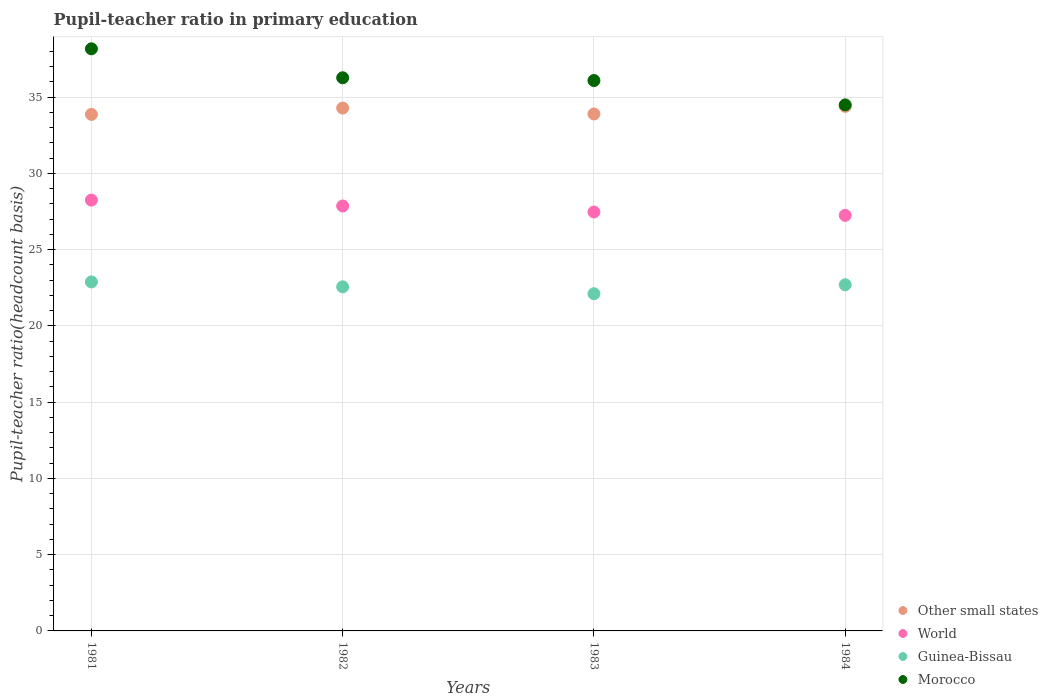How many different coloured dotlines are there?
Keep it short and to the point. 4. Is the number of dotlines equal to the number of legend labels?
Keep it short and to the point. Yes. What is the pupil-teacher ratio in primary education in Morocco in 1983?
Provide a short and direct response. 36.09. Across all years, what is the maximum pupil-teacher ratio in primary education in World?
Give a very brief answer. 28.25. Across all years, what is the minimum pupil-teacher ratio in primary education in Morocco?
Ensure brevity in your answer.  34.5. In which year was the pupil-teacher ratio in primary education in World minimum?
Offer a very short reply. 1984. What is the total pupil-teacher ratio in primary education in Morocco in the graph?
Keep it short and to the point. 145.03. What is the difference between the pupil-teacher ratio in primary education in Morocco in 1983 and that in 1984?
Make the answer very short. 1.6. What is the difference between the pupil-teacher ratio in primary education in Morocco in 1981 and the pupil-teacher ratio in primary education in World in 1982?
Make the answer very short. 10.31. What is the average pupil-teacher ratio in primary education in Other small states per year?
Keep it short and to the point. 34.11. In the year 1981, what is the difference between the pupil-teacher ratio in primary education in Guinea-Bissau and pupil-teacher ratio in primary education in Other small states?
Ensure brevity in your answer.  -10.99. What is the ratio of the pupil-teacher ratio in primary education in World in 1982 to that in 1984?
Your response must be concise. 1.02. Is the pupil-teacher ratio in primary education in Other small states in 1981 less than that in 1983?
Your response must be concise. Yes. Is the difference between the pupil-teacher ratio in primary education in Guinea-Bissau in 1982 and 1984 greater than the difference between the pupil-teacher ratio in primary education in Other small states in 1982 and 1984?
Provide a succinct answer. No. What is the difference between the highest and the second highest pupil-teacher ratio in primary education in Other small states?
Ensure brevity in your answer.  0.11. What is the difference between the highest and the lowest pupil-teacher ratio in primary education in Guinea-Bissau?
Offer a very short reply. 0.77. Is the sum of the pupil-teacher ratio in primary education in Other small states in 1982 and 1984 greater than the maximum pupil-teacher ratio in primary education in Morocco across all years?
Provide a short and direct response. Yes. Is it the case that in every year, the sum of the pupil-teacher ratio in primary education in World and pupil-teacher ratio in primary education in Morocco  is greater than the pupil-teacher ratio in primary education in Other small states?
Make the answer very short. Yes. Is the pupil-teacher ratio in primary education in World strictly less than the pupil-teacher ratio in primary education in Morocco over the years?
Your answer should be very brief. Yes. Are the values on the major ticks of Y-axis written in scientific E-notation?
Provide a succinct answer. No. What is the title of the graph?
Your answer should be very brief. Pupil-teacher ratio in primary education. Does "Arab World" appear as one of the legend labels in the graph?
Your answer should be compact. No. What is the label or title of the X-axis?
Your answer should be compact. Years. What is the label or title of the Y-axis?
Your response must be concise. Pupil-teacher ratio(headcount basis). What is the Pupil-teacher ratio(headcount basis) in Other small states in 1981?
Your answer should be compact. 33.87. What is the Pupil-teacher ratio(headcount basis) in World in 1981?
Make the answer very short. 28.25. What is the Pupil-teacher ratio(headcount basis) of Guinea-Bissau in 1981?
Offer a very short reply. 22.89. What is the Pupil-teacher ratio(headcount basis) of Morocco in 1981?
Give a very brief answer. 38.17. What is the Pupil-teacher ratio(headcount basis) in Other small states in 1982?
Offer a terse response. 34.29. What is the Pupil-teacher ratio(headcount basis) of World in 1982?
Make the answer very short. 27.87. What is the Pupil-teacher ratio(headcount basis) in Guinea-Bissau in 1982?
Ensure brevity in your answer.  22.57. What is the Pupil-teacher ratio(headcount basis) of Morocco in 1982?
Provide a short and direct response. 36.27. What is the Pupil-teacher ratio(headcount basis) in Other small states in 1983?
Your response must be concise. 33.9. What is the Pupil-teacher ratio(headcount basis) of World in 1983?
Your response must be concise. 27.47. What is the Pupil-teacher ratio(headcount basis) of Guinea-Bissau in 1983?
Ensure brevity in your answer.  22.11. What is the Pupil-teacher ratio(headcount basis) of Morocco in 1983?
Offer a very short reply. 36.09. What is the Pupil-teacher ratio(headcount basis) in Other small states in 1984?
Your response must be concise. 34.4. What is the Pupil-teacher ratio(headcount basis) of World in 1984?
Offer a very short reply. 27.25. What is the Pupil-teacher ratio(headcount basis) in Guinea-Bissau in 1984?
Offer a very short reply. 22.7. What is the Pupil-teacher ratio(headcount basis) of Morocco in 1984?
Your response must be concise. 34.5. Across all years, what is the maximum Pupil-teacher ratio(headcount basis) of Other small states?
Your response must be concise. 34.4. Across all years, what is the maximum Pupil-teacher ratio(headcount basis) of World?
Your response must be concise. 28.25. Across all years, what is the maximum Pupil-teacher ratio(headcount basis) in Guinea-Bissau?
Give a very brief answer. 22.89. Across all years, what is the maximum Pupil-teacher ratio(headcount basis) of Morocco?
Ensure brevity in your answer.  38.17. Across all years, what is the minimum Pupil-teacher ratio(headcount basis) of Other small states?
Make the answer very short. 33.87. Across all years, what is the minimum Pupil-teacher ratio(headcount basis) of World?
Your response must be concise. 27.25. Across all years, what is the minimum Pupil-teacher ratio(headcount basis) in Guinea-Bissau?
Your answer should be very brief. 22.11. Across all years, what is the minimum Pupil-teacher ratio(headcount basis) in Morocco?
Your answer should be very brief. 34.5. What is the total Pupil-teacher ratio(headcount basis) in Other small states in the graph?
Offer a very short reply. 136.46. What is the total Pupil-teacher ratio(headcount basis) in World in the graph?
Offer a very short reply. 110.84. What is the total Pupil-teacher ratio(headcount basis) in Guinea-Bissau in the graph?
Provide a succinct answer. 90.26. What is the total Pupil-teacher ratio(headcount basis) of Morocco in the graph?
Offer a very short reply. 145.03. What is the difference between the Pupil-teacher ratio(headcount basis) of Other small states in 1981 and that in 1982?
Your answer should be compact. -0.42. What is the difference between the Pupil-teacher ratio(headcount basis) in World in 1981 and that in 1982?
Your answer should be compact. 0.39. What is the difference between the Pupil-teacher ratio(headcount basis) in Guinea-Bissau in 1981 and that in 1982?
Your answer should be very brief. 0.32. What is the difference between the Pupil-teacher ratio(headcount basis) in Morocco in 1981 and that in 1982?
Offer a very short reply. 1.9. What is the difference between the Pupil-teacher ratio(headcount basis) of Other small states in 1981 and that in 1983?
Offer a terse response. -0.03. What is the difference between the Pupil-teacher ratio(headcount basis) of World in 1981 and that in 1983?
Provide a succinct answer. 0.78. What is the difference between the Pupil-teacher ratio(headcount basis) of Guinea-Bissau in 1981 and that in 1983?
Give a very brief answer. 0.77. What is the difference between the Pupil-teacher ratio(headcount basis) of Morocco in 1981 and that in 1983?
Keep it short and to the point. 2.08. What is the difference between the Pupil-teacher ratio(headcount basis) in Other small states in 1981 and that in 1984?
Offer a very short reply. -0.53. What is the difference between the Pupil-teacher ratio(headcount basis) in World in 1981 and that in 1984?
Provide a short and direct response. 1. What is the difference between the Pupil-teacher ratio(headcount basis) in Guinea-Bissau in 1981 and that in 1984?
Provide a succinct answer. 0.19. What is the difference between the Pupil-teacher ratio(headcount basis) in Morocco in 1981 and that in 1984?
Make the answer very short. 3.68. What is the difference between the Pupil-teacher ratio(headcount basis) in Other small states in 1982 and that in 1983?
Ensure brevity in your answer.  0.39. What is the difference between the Pupil-teacher ratio(headcount basis) of World in 1982 and that in 1983?
Ensure brevity in your answer.  0.4. What is the difference between the Pupil-teacher ratio(headcount basis) of Guinea-Bissau in 1982 and that in 1983?
Offer a very short reply. 0.45. What is the difference between the Pupil-teacher ratio(headcount basis) of Morocco in 1982 and that in 1983?
Provide a short and direct response. 0.18. What is the difference between the Pupil-teacher ratio(headcount basis) of Other small states in 1982 and that in 1984?
Offer a very short reply. -0.11. What is the difference between the Pupil-teacher ratio(headcount basis) of World in 1982 and that in 1984?
Ensure brevity in your answer.  0.62. What is the difference between the Pupil-teacher ratio(headcount basis) of Guinea-Bissau in 1982 and that in 1984?
Offer a terse response. -0.14. What is the difference between the Pupil-teacher ratio(headcount basis) of Morocco in 1982 and that in 1984?
Offer a terse response. 1.78. What is the difference between the Pupil-teacher ratio(headcount basis) in Other small states in 1983 and that in 1984?
Give a very brief answer. -0.5. What is the difference between the Pupil-teacher ratio(headcount basis) in World in 1983 and that in 1984?
Your response must be concise. 0.22. What is the difference between the Pupil-teacher ratio(headcount basis) of Guinea-Bissau in 1983 and that in 1984?
Offer a terse response. -0.59. What is the difference between the Pupil-teacher ratio(headcount basis) in Morocco in 1983 and that in 1984?
Provide a short and direct response. 1.6. What is the difference between the Pupil-teacher ratio(headcount basis) of Other small states in 1981 and the Pupil-teacher ratio(headcount basis) of World in 1982?
Your answer should be compact. 6.01. What is the difference between the Pupil-teacher ratio(headcount basis) of Other small states in 1981 and the Pupil-teacher ratio(headcount basis) of Guinea-Bissau in 1982?
Keep it short and to the point. 11.31. What is the difference between the Pupil-teacher ratio(headcount basis) of Other small states in 1981 and the Pupil-teacher ratio(headcount basis) of Morocco in 1982?
Your answer should be very brief. -2.4. What is the difference between the Pupil-teacher ratio(headcount basis) in World in 1981 and the Pupil-teacher ratio(headcount basis) in Guinea-Bissau in 1982?
Your answer should be very brief. 5.69. What is the difference between the Pupil-teacher ratio(headcount basis) of World in 1981 and the Pupil-teacher ratio(headcount basis) of Morocco in 1982?
Your answer should be compact. -8.02. What is the difference between the Pupil-teacher ratio(headcount basis) in Guinea-Bissau in 1981 and the Pupil-teacher ratio(headcount basis) in Morocco in 1982?
Make the answer very short. -13.39. What is the difference between the Pupil-teacher ratio(headcount basis) in Other small states in 1981 and the Pupil-teacher ratio(headcount basis) in World in 1983?
Your answer should be compact. 6.4. What is the difference between the Pupil-teacher ratio(headcount basis) of Other small states in 1981 and the Pupil-teacher ratio(headcount basis) of Guinea-Bissau in 1983?
Give a very brief answer. 11.76. What is the difference between the Pupil-teacher ratio(headcount basis) of Other small states in 1981 and the Pupil-teacher ratio(headcount basis) of Morocco in 1983?
Offer a terse response. -2.22. What is the difference between the Pupil-teacher ratio(headcount basis) in World in 1981 and the Pupil-teacher ratio(headcount basis) in Guinea-Bissau in 1983?
Offer a terse response. 6.14. What is the difference between the Pupil-teacher ratio(headcount basis) in World in 1981 and the Pupil-teacher ratio(headcount basis) in Morocco in 1983?
Provide a succinct answer. -7.84. What is the difference between the Pupil-teacher ratio(headcount basis) of Guinea-Bissau in 1981 and the Pupil-teacher ratio(headcount basis) of Morocco in 1983?
Provide a succinct answer. -13.21. What is the difference between the Pupil-teacher ratio(headcount basis) in Other small states in 1981 and the Pupil-teacher ratio(headcount basis) in World in 1984?
Your response must be concise. 6.62. What is the difference between the Pupil-teacher ratio(headcount basis) in Other small states in 1981 and the Pupil-teacher ratio(headcount basis) in Guinea-Bissau in 1984?
Keep it short and to the point. 11.17. What is the difference between the Pupil-teacher ratio(headcount basis) of Other small states in 1981 and the Pupil-teacher ratio(headcount basis) of Morocco in 1984?
Ensure brevity in your answer.  -0.62. What is the difference between the Pupil-teacher ratio(headcount basis) of World in 1981 and the Pupil-teacher ratio(headcount basis) of Guinea-Bissau in 1984?
Provide a short and direct response. 5.55. What is the difference between the Pupil-teacher ratio(headcount basis) in World in 1981 and the Pupil-teacher ratio(headcount basis) in Morocco in 1984?
Provide a succinct answer. -6.24. What is the difference between the Pupil-teacher ratio(headcount basis) in Guinea-Bissau in 1981 and the Pupil-teacher ratio(headcount basis) in Morocco in 1984?
Keep it short and to the point. -11.61. What is the difference between the Pupil-teacher ratio(headcount basis) in Other small states in 1982 and the Pupil-teacher ratio(headcount basis) in World in 1983?
Provide a short and direct response. 6.82. What is the difference between the Pupil-teacher ratio(headcount basis) of Other small states in 1982 and the Pupil-teacher ratio(headcount basis) of Guinea-Bissau in 1983?
Ensure brevity in your answer.  12.18. What is the difference between the Pupil-teacher ratio(headcount basis) of Other small states in 1982 and the Pupil-teacher ratio(headcount basis) of Morocco in 1983?
Make the answer very short. -1.8. What is the difference between the Pupil-teacher ratio(headcount basis) in World in 1982 and the Pupil-teacher ratio(headcount basis) in Guinea-Bissau in 1983?
Offer a very short reply. 5.76. What is the difference between the Pupil-teacher ratio(headcount basis) in World in 1982 and the Pupil-teacher ratio(headcount basis) in Morocco in 1983?
Make the answer very short. -8.22. What is the difference between the Pupil-teacher ratio(headcount basis) of Guinea-Bissau in 1982 and the Pupil-teacher ratio(headcount basis) of Morocco in 1983?
Ensure brevity in your answer.  -13.53. What is the difference between the Pupil-teacher ratio(headcount basis) of Other small states in 1982 and the Pupil-teacher ratio(headcount basis) of World in 1984?
Ensure brevity in your answer.  7.04. What is the difference between the Pupil-teacher ratio(headcount basis) in Other small states in 1982 and the Pupil-teacher ratio(headcount basis) in Guinea-Bissau in 1984?
Your answer should be compact. 11.59. What is the difference between the Pupil-teacher ratio(headcount basis) in Other small states in 1982 and the Pupil-teacher ratio(headcount basis) in Morocco in 1984?
Give a very brief answer. -0.21. What is the difference between the Pupil-teacher ratio(headcount basis) of World in 1982 and the Pupil-teacher ratio(headcount basis) of Guinea-Bissau in 1984?
Provide a short and direct response. 5.17. What is the difference between the Pupil-teacher ratio(headcount basis) in World in 1982 and the Pupil-teacher ratio(headcount basis) in Morocco in 1984?
Your response must be concise. -6.63. What is the difference between the Pupil-teacher ratio(headcount basis) in Guinea-Bissau in 1982 and the Pupil-teacher ratio(headcount basis) in Morocco in 1984?
Offer a very short reply. -11.93. What is the difference between the Pupil-teacher ratio(headcount basis) in Other small states in 1983 and the Pupil-teacher ratio(headcount basis) in World in 1984?
Keep it short and to the point. 6.65. What is the difference between the Pupil-teacher ratio(headcount basis) of Other small states in 1983 and the Pupil-teacher ratio(headcount basis) of Guinea-Bissau in 1984?
Provide a short and direct response. 11.2. What is the difference between the Pupil-teacher ratio(headcount basis) of Other small states in 1983 and the Pupil-teacher ratio(headcount basis) of Morocco in 1984?
Your answer should be very brief. -0.6. What is the difference between the Pupil-teacher ratio(headcount basis) of World in 1983 and the Pupil-teacher ratio(headcount basis) of Guinea-Bissau in 1984?
Give a very brief answer. 4.77. What is the difference between the Pupil-teacher ratio(headcount basis) of World in 1983 and the Pupil-teacher ratio(headcount basis) of Morocco in 1984?
Offer a very short reply. -7.02. What is the difference between the Pupil-teacher ratio(headcount basis) of Guinea-Bissau in 1983 and the Pupil-teacher ratio(headcount basis) of Morocco in 1984?
Offer a very short reply. -12.39. What is the average Pupil-teacher ratio(headcount basis) of Other small states per year?
Offer a terse response. 34.11. What is the average Pupil-teacher ratio(headcount basis) in World per year?
Give a very brief answer. 27.71. What is the average Pupil-teacher ratio(headcount basis) in Guinea-Bissau per year?
Your response must be concise. 22.57. What is the average Pupil-teacher ratio(headcount basis) of Morocco per year?
Ensure brevity in your answer.  36.26. In the year 1981, what is the difference between the Pupil-teacher ratio(headcount basis) in Other small states and Pupil-teacher ratio(headcount basis) in World?
Ensure brevity in your answer.  5.62. In the year 1981, what is the difference between the Pupil-teacher ratio(headcount basis) in Other small states and Pupil-teacher ratio(headcount basis) in Guinea-Bissau?
Ensure brevity in your answer.  10.99. In the year 1981, what is the difference between the Pupil-teacher ratio(headcount basis) of Other small states and Pupil-teacher ratio(headcount basis) of Morocco?
Make the answer very short. -4.3. In the year 1981, what is the difference between the Pupil-teacher ratio(headcount basis) of World and Pupil-teacher ratio(headcount basis) of Guinea-Bissau?
Provide a short and direct response. 5.37. In the year 1981, what is the difference between the Pupil-teacher ratio(headcount basis) of World and Pupil-teacher ratio(headcount basis) of Morocco?
Your response must be concise. -9.92. In the year 1981, what is the difference between the Pupil-teacher ratio(headcount basis) of Guinea-Bissau and Pupil-teacher ratio(headcount basis) of Morocco?
Offer a very short reply. -15.29. In the year 1982, what is the difference between the Pupil-teacher ratio(headcount basis) of Other small states and Pupil-teacher ratio(headcount basis) of World?
Offer a very short reply. 6.42. In the year 1982, what is the difference between the Pupil-teacher ratio(headcount basis) of Other small states and Pupil-teacher ratio(headcount basis) of Guinea-Bissau?
Make the answer very short. 11.72. In the year 1982, what is the difference between the Pupil-teacher ratio(headcount basis) in Other small states and Pupil-teacher ratio(headcount basis) in Morocco?
Your response must be concise. -1.99. In the year 1982, what is the difference between the Pupil-teacher ratio(headcount basis) of World and Pupil-teacher ratio(headcount basis) of Guinea-Bissau?
Ensure brevity in your answer.  5.3. In the year 1982, what is the difference between the Pupil-teacher ratio(headcount basis) in World and Pupil-teacher ratio(headcount basis) in Morocco?
Your answer should be very brief. -8.41. In the year 1982, what is the difference between the Pupil-teacher ratio(headcount basis) of Guinea-Bissau and Pupil-teacher ratio(headcount basis) of Morocco?
Your answer should be very brief. -13.71. In the year 1983, what is the difference between the Pupil-teacher ratio(headcount basis) in Other small states and Pupil-teacher ratio(headcount basis) in World?
Make the answer very short. 6.43. In the year 1983, what is the difference between the Pupil-teacher ratio(headcount basis) in Other small states and Pupil-teacher ratio(headcount basis) in Guinea-Bissau?
Your response must be concise. 11.79. In the year 1983, what is the difference between the Pupil-teacher ratio(headcount basis) of Other small states and Pupil-teacher ratio(headcount basis) of Morocco?
Give a very brief answer. -2.19. In the year 1983, what is the difference between the Pupil-teacher ratio(headcount basis) in World and Pupil-teacher ratio(headcount basis) in Guinea-Bissau?
Your response must be concise. 5.36. In the year 1983, what is the difference between the Pupil-teacher ratio(headcount basis) in World and Pupil-teacher ratio(headcount basis) in Morocco?
Make the answer very short. -8.62. In the year 1983, what is the difference between the Pupil-teacher ratio(headcount basis) in Guinea-Bissau and Pupil-teacher ratio(headcount basis) in Morocco?
Your answer should be compact. -13.98. In the year 1984, what is the difference between the Pupil-teacher ratio(headcount basis) in Other small states and Pupil-teacher ratio(headcount basis) in World?
Provide a succinct answer. 7.15. In the year 1984, what is the difference between the Pupil-teacher ratio(headcount basis) in Other small states and Pupil-teacher ratio(headcount basis) in Guinea-Bissau?
Your answer should be compact. 11.7. In the year 1984, what is the difference between the Pupil-teacher ratio(headcount basis) of Other small states and Pupil-teacher ratio(headcount basis) of Morocco?
Provide a short and direct response. -0.1. In the year 1984, what is the difference between the Pupil-teacher ratio(headcount basis) in World and Pupil-teacher ratio(headcount basis) in Guinea-Bissau?
Give a very brief answer. 4.55. In the year 1984, what is the difference between the Pupil-teacher ratio(headcount basis) of World and Pupil-teacher ratio(headcount basis) of Morocco?
Make the answer very short. -7.25. In the year 1984, what is the difference between the Pupil-teacher ratio(headcount basis) in Guinea-Bissau and Pupil-teacher ratio(headcount basis) in Morocco?
Keep it short and to the point. -11.8. What is the ratio of the Pupil-teacher ratio(headcount basis) of Other small states in 1981 to that in 1982?
Keep it short and to the point. 0.99. What is the ratio of the Pupil-teacher ratio(headcount basis) of World in 1981 to that in 1982?
Offer a very short reply. 1.01. What is the ratio of the Pupil-teacher ratio(headcount basis) of Guinea-Bissau in 1981 to that in 1982?
Keep it short and to the point. 1.01. What is the ratio of the Pupil-teacher ratio(headcount basis) of Morocco in 1981 to that in 1982?
Offer a terse response. 1.05. What is the ratio of the Pupil-teacher ratio(headcount basis) of Other small states in 1981 to that in 1983?
Offer a very short reply. 1. What is the ratio of the Pupil-teacher ratio(headcount basis) of World in 1981 to that in 1983?
Give a very brief answer. 1.03. What is the ratio of the Pupil-teacher ratio(headcount basis) in Guinea-Bissau in 1981 to that in 1983?
Your answer should be compact. 1.03. What is the ratio of the Pupil-teacher ratio(headcount basis) in Morocco in 1981 to that in 1983?
Provide a succinct answer. 1.06. What is the ratio of the Pupil-teacher ratio(headcount basis) of Other small states in 1981 to that in 1984?
Give a very brief answer. 0.98. What is the ratio of the Pupil-teacher ratio(headcount basis) of World in 1981 to that in 1984?
Your response must be concise. 1.04. What is the ratio of the Pupil-teacher ratio(headcount basis) in Guinea-Bissau in 1981 to that in 1984?
Ensure brevity in your answer.  1.01. What is the ratio of the Pupil-teacher ratio(headcount basis) in Morocco in 1981 to that in 1984?
Offer a very short reply. 1.11. What is the ratio of the Pupil-teacher ratio(headcount basis) of Other small states in 1982 to that in 1983?
Provide a succinct answer. 1.01. What is the ratio of the Pupil-teacher ratio(headcount basis) in World in 1982 to that in 1983?
Offer a terse response. 1.01. What is the ratio of the Pupil-teacher ratio(headcount basis) of Guinea-Bissau in 1982 to that in 1983?
Offer a very short reply. 1.02. What is the ratio of the Pupil-teacher ratio(headcount basis) in Morocco in 1982 to that in 1983?
Provide a short and direct response. 1. What is the ratio of the Pupil-teacher ratio(headcount basis) of World in 1982 to that in 1984?
Offer a terse response. 1.02. What is the ratio of the Pupil-teacher ratio(headcount basis) in Morocco in 1982 to that in 1984?
Your response must be concise. 1.05. What is the ratio of the Pupil-teacher ratio(headcount basis) in Other small states in 1983 to that in 1984?
Provide a short and direct response. 0.99. What is the ratio of the Pupil-teacher ratio(headcount basis) of World in 1983 to that in 1984?
Make the answer very short. 1.01. What is the ratio of the Pupil-teacher ratio(headcount basis) in Morocco in 1983 to that in 1984?
Give a very brief answer. 1.05. What is the difference between the highest and the second highest Pupil-teacher ratio(headcount basis) of Other small states?
Keep it short and to the point. 0.11. What is the difference between the highest and the second highest Pupil-teacher ratio(headcount basis) of World?
Your answer should be compact. 0.39. What is the difference between the highest and the second highest Pupil-teacher ratio(headcount basis) of Guinea-Bissau?
Keep it short and to the point. 0.19. What is the difference between the highest and the second highest Pupil-teacher ratio(headcount basis) of Morocco?
Make the answer very short. 1.9. What is the difference between the highest and the lowest Pupil-teacher ratio(headcount basis) in Other small states?
Your answer should be compact. 0.53. What is the difference between the highest and the lowest Pupil-teacher ratio(headcount basis) of Guinea-Bissau?
Offer a terse response. 0.77. What is the difference between the highest and the lowest Pupil-teacher ratio(headcount basis) of Morocco?
Your answer should be compact. 3.68. 